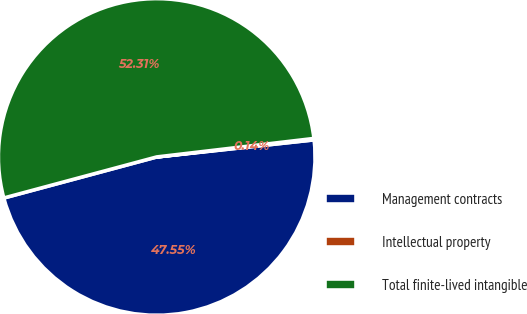Convert chart to OTSL. <chart><loc_0><loc_0><loc_500><loc_500><pie_chart><fcel>Management contracts<fcel>Intellectual property<fcel>Total finite-lived intangible<nl><fcel>47.55%<fcel>0.14%<fcel>52.31%<nl></chart> 